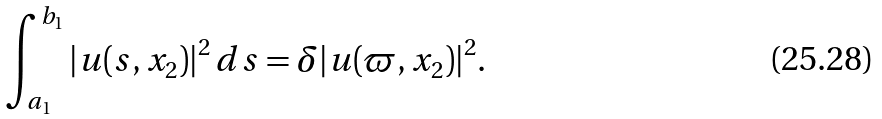Convert formula to latex. <formula><loc_0><loc_0><loc_500><loc_500>\int _ { a _ { 1 } } ^ { b _ { 1 } } | u ( s , x _ { 2 } ) | ^ { 2 } \, d s = \delta | u ( \varpi , x _ { 2 } ) | ^ { 2 } .</formula> 